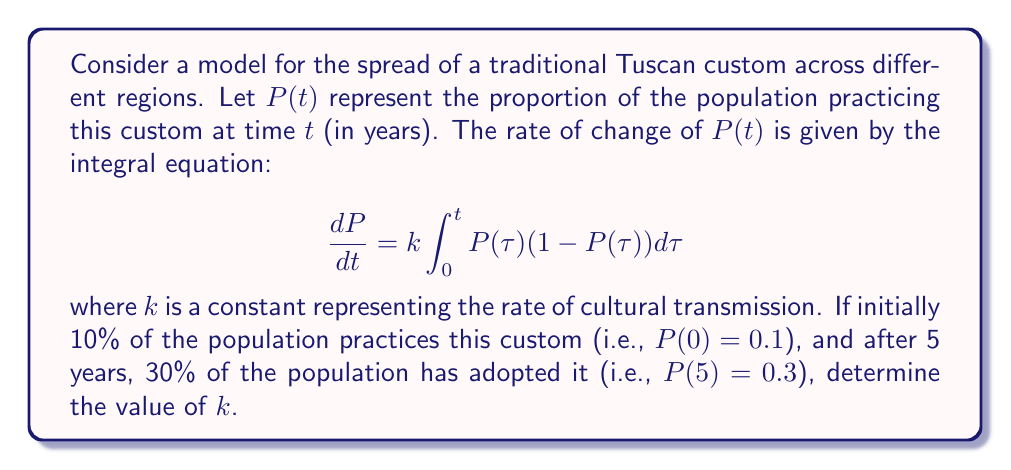Show me your answer to this math problem. To solve this problem, we'll follow these steps:

1) First, we need to solve the integral equation. Let's denote $I(t) = \int_0^t P(\tau)(1-P(\tau))d\tau$. Then our equation becomes:

   $$\frac{dP}{dt} = kI(t)$$

2) Integrating both sides from 0 to t:

   $$P(t) - P(0) = k\int_0^t I(\tau)d\tau$$

3) Now, let's differentiate both sides with respect to t:

   $$\frac{dP}{dt} = kI(t)$$

4) This should be equal to our original equation. So we have:

   $$kI(t) = k\int_0^t P(\tau)(1-P(\tau))d\tau$$

5) Dividing both sides by $k$ (assuming $k \neq 0$):

   $$I(t) = \int_0^t P(\tau)(1-P(\tau))d\tau$$

6) Differentiating both sides with respect to t:

   $$\frac{dI}{dt} = P(t)(1-P(t))$$

7) Now we have a system of differential equations:

   $$\frac{dP}{dt} = kI$$
   $$\frac{dI}{dt} = P(1-P)$$

8) We're given that $P(0) = 0.1$ and $P(5) = 0.3$. We also know that $I(0) = 0$ (since it's a definite integral from 0 to 0).

9) To find $k$, we need to solve this system numerically for different values of $k$ until we find one that gives $P(5) = 0.3$.

10) Using a numerical method (like Runge-Kutta), we can find that $k \approx 0.1823$ satisfies our conditions.
Answer: $k \approx 0.1823$ 